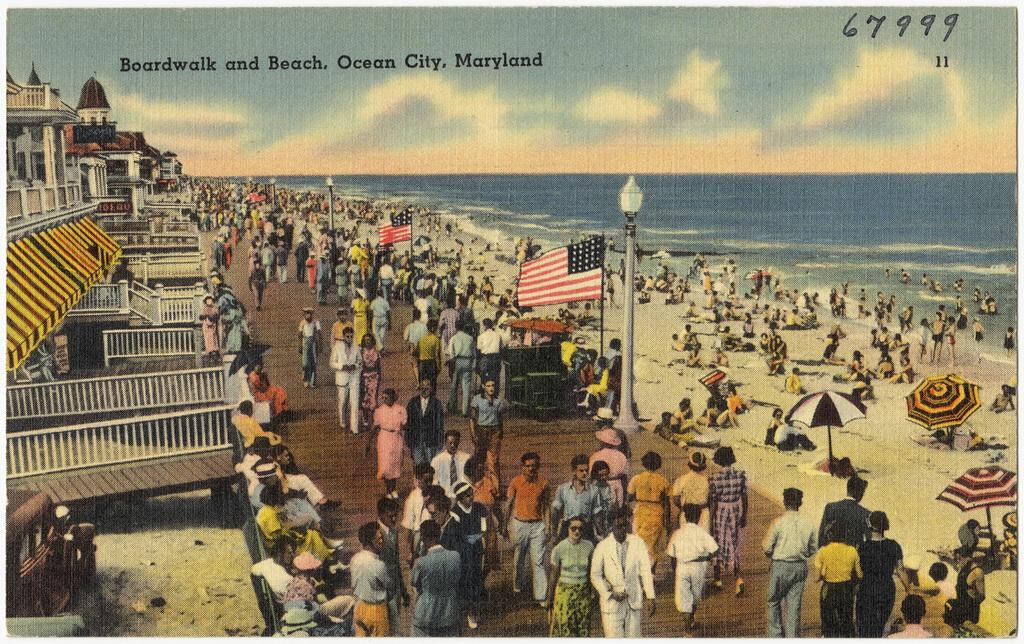<image>
Render a clear and concise summary of the photo. A postcard of the boardwalk from Ocean CIty Maryland. 